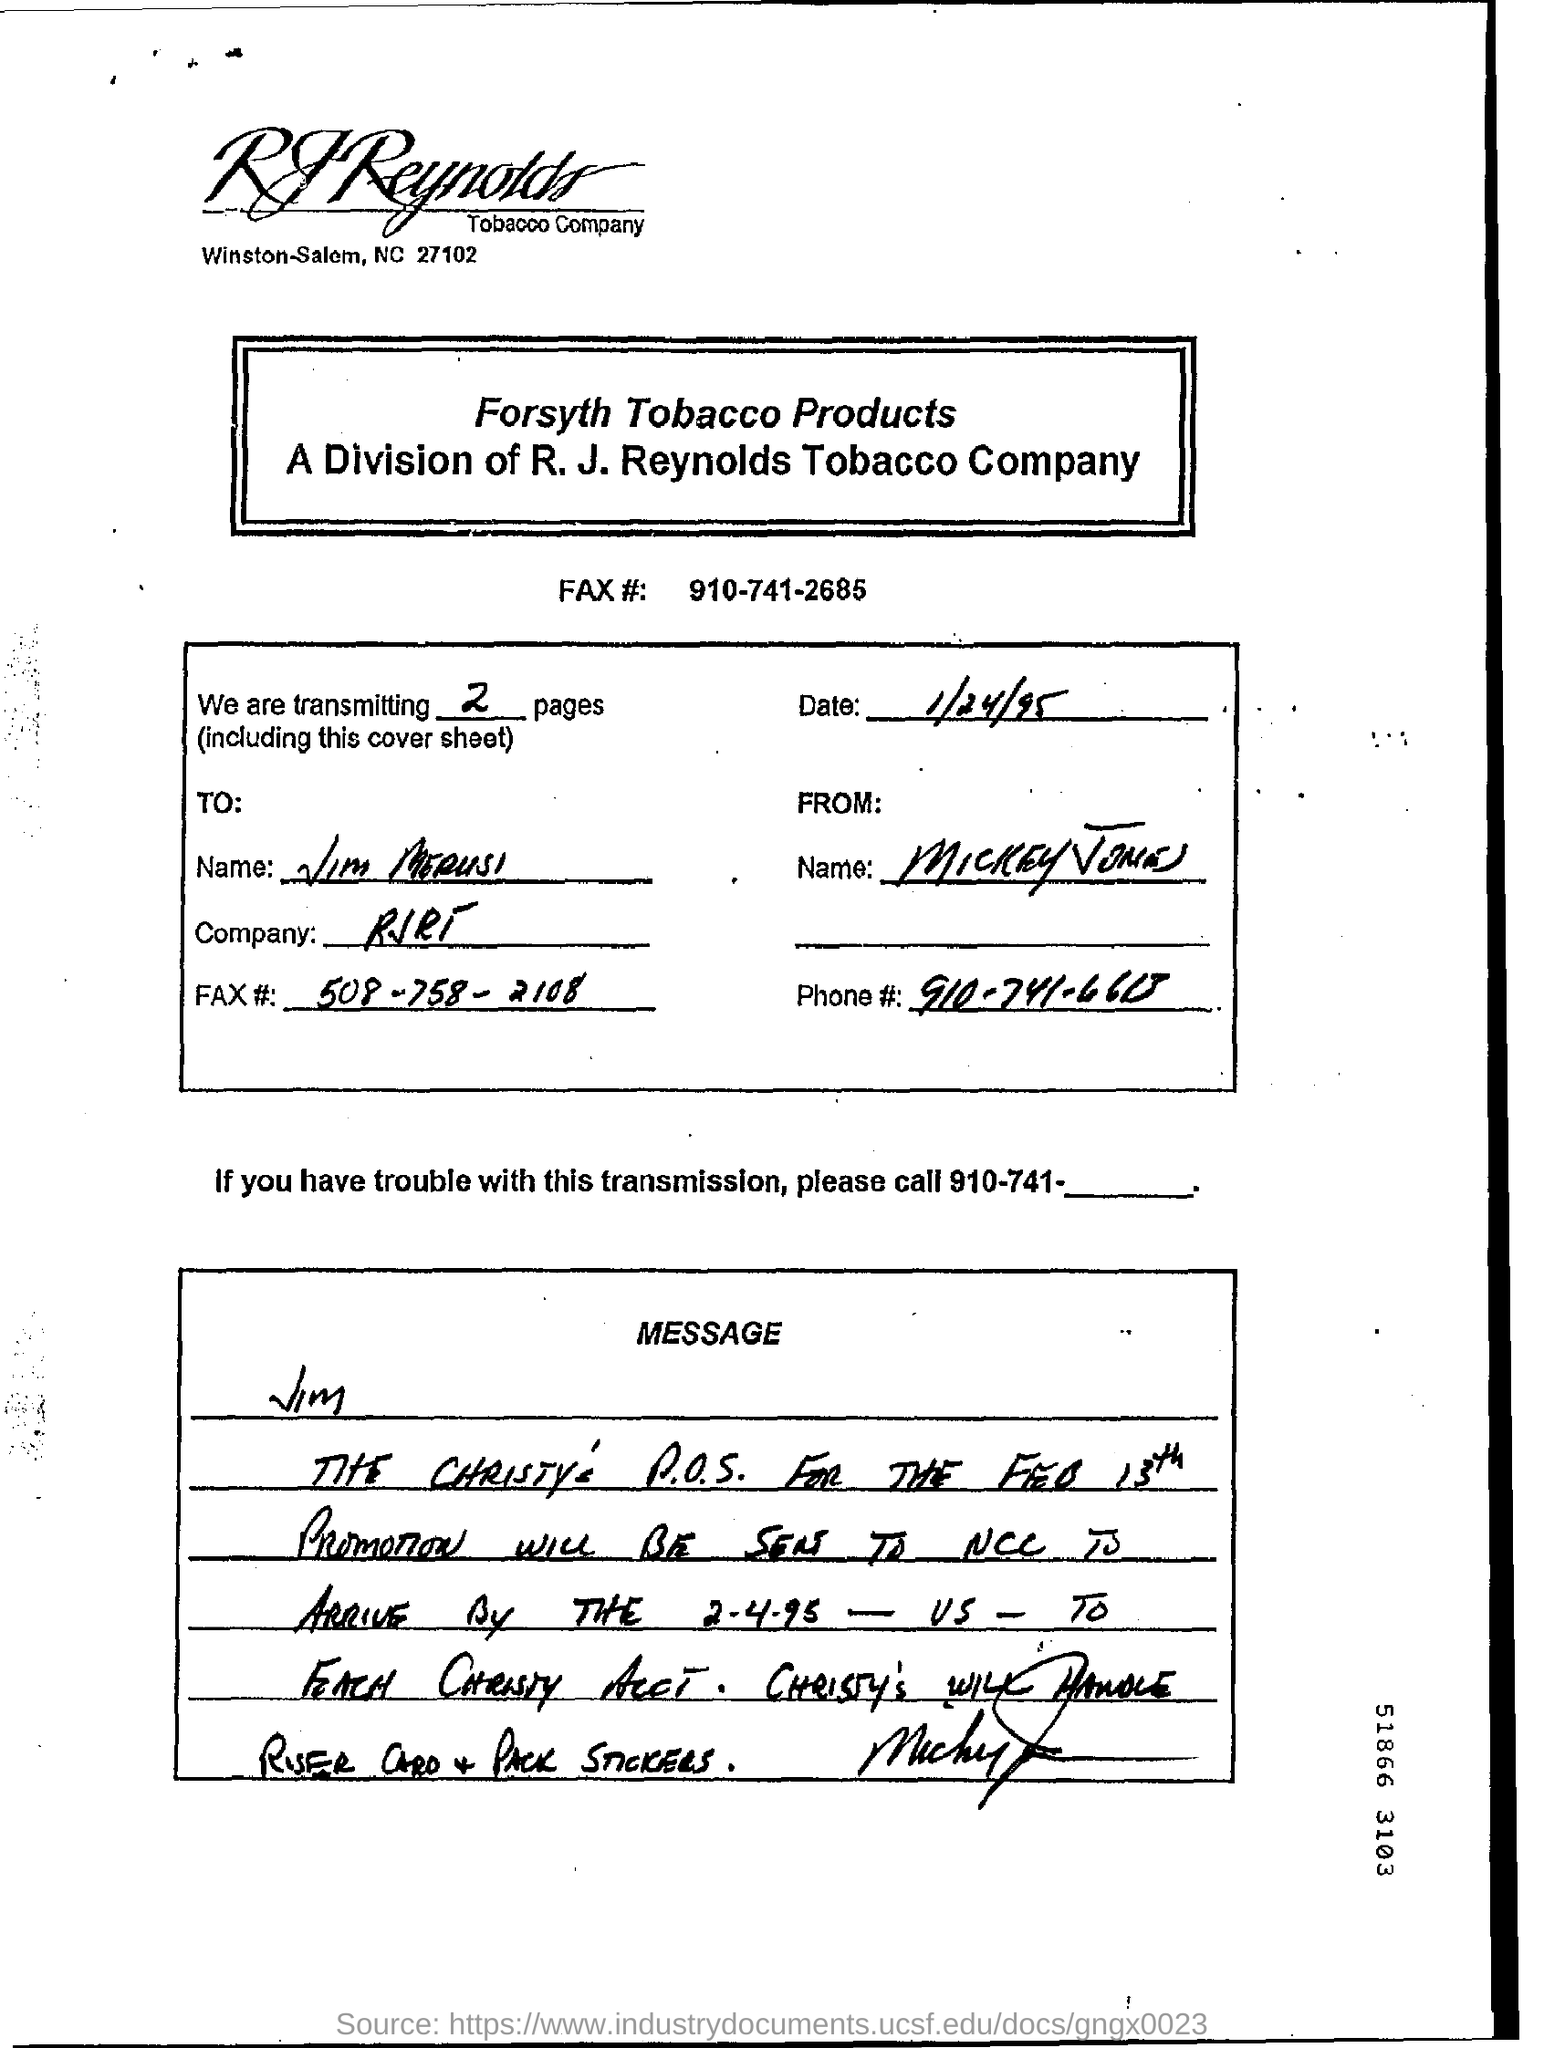How many pages are being transmitted?
Ensure brevity in your answer.  2. 